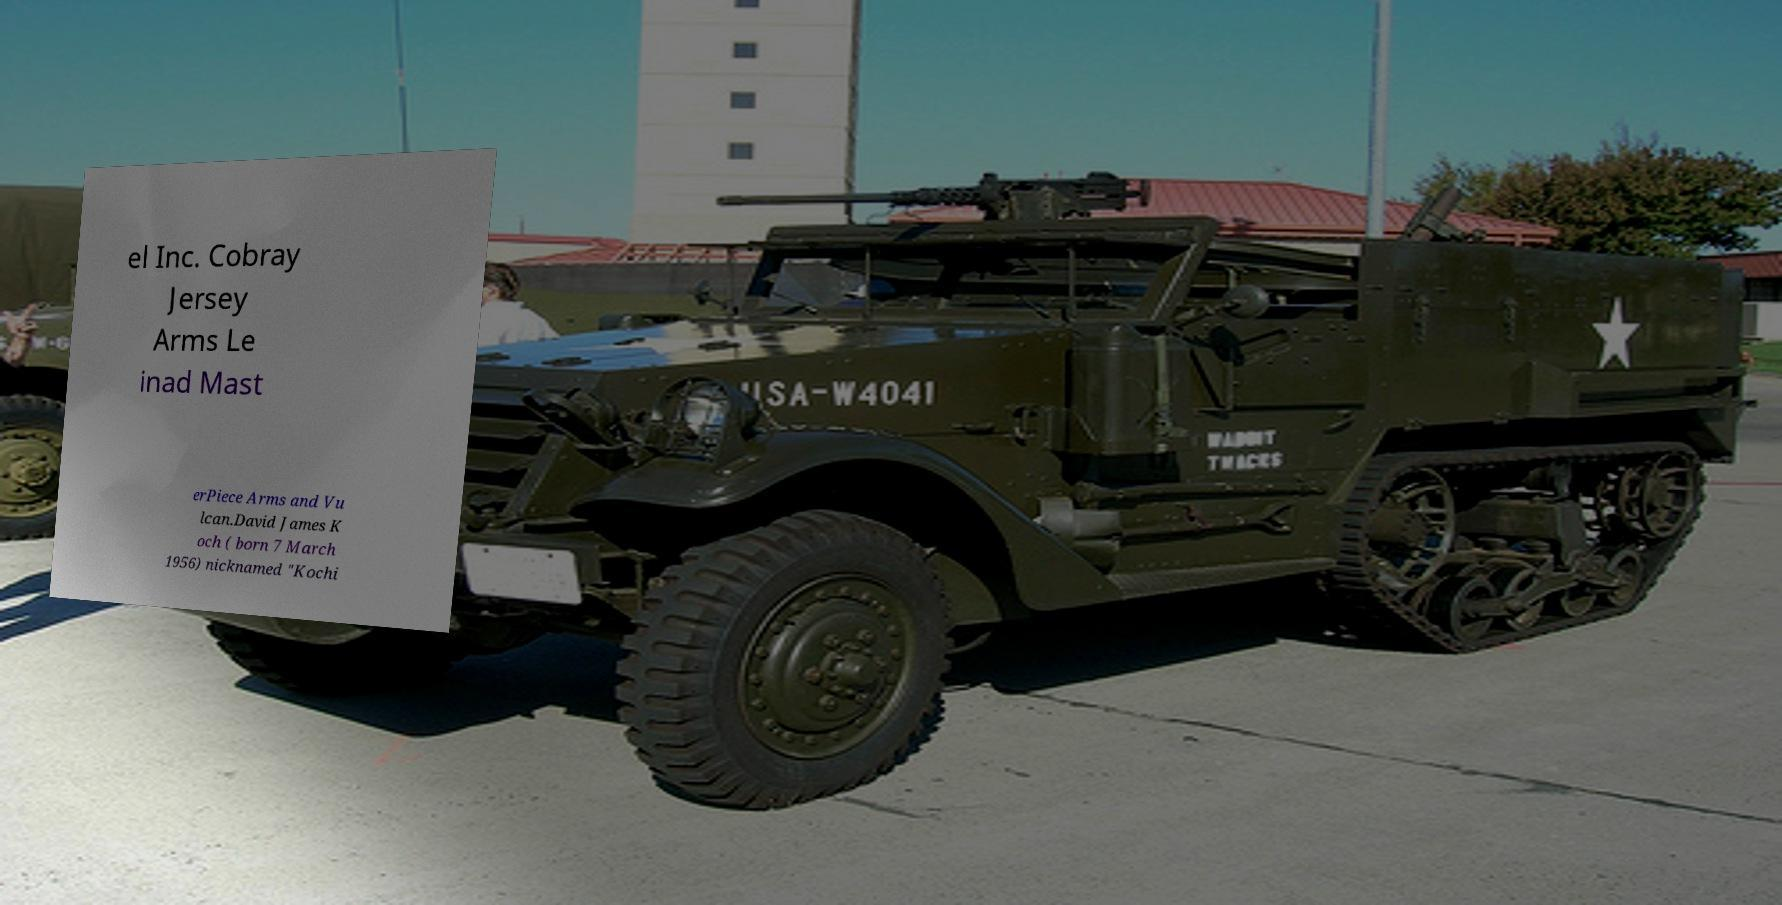Can you accurately transcribe the text from the provided image for me? el Inc. Cobray Jersey Arms Le inad Mast erPiece Arms and Vu lcan.David James K och ( born 7 March 1956) nicknamed "Kochi 